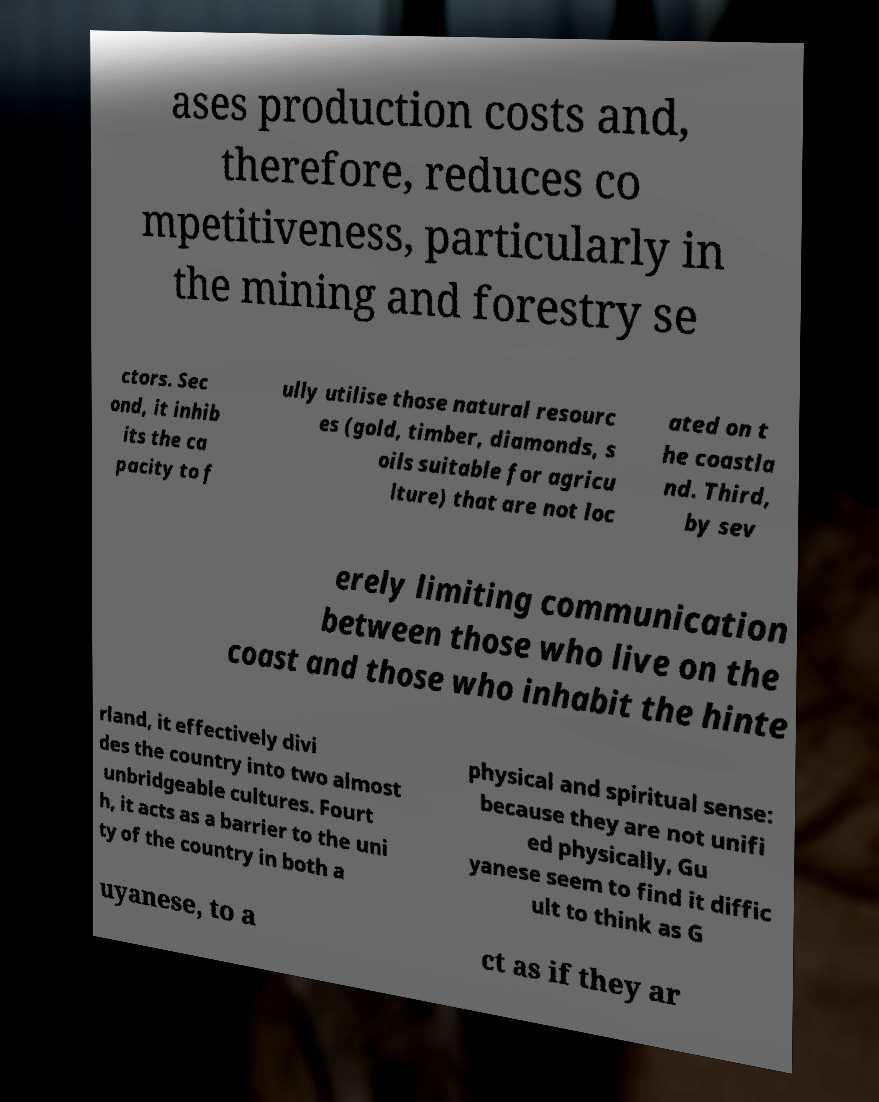Please read and relay the text visible in this image. What does it say? ases production costs and, therefore, reduces co mpetitiveness, particularly in the mining and forestry se ctors. Sec ond, it inhib its the ca pacity to f ully utilise those natural resourc es (gold, timber, diamonds, s oils suitable for agricu lture) that are not loc ated on t he coastla nd. Third, by sev erely limiting communication between those who live on the coast and those who inhabit the hinte rland, it effectively divi des the country into two almost unbridgeable cultures. Fourt h, it acts as a barrier to the uni ty of the country in both a physical and spiritual sense: because they are not unifi ed physically, Gu yanese seem to find it diffic ult to think as G uyanese, to a ct as if they ar 